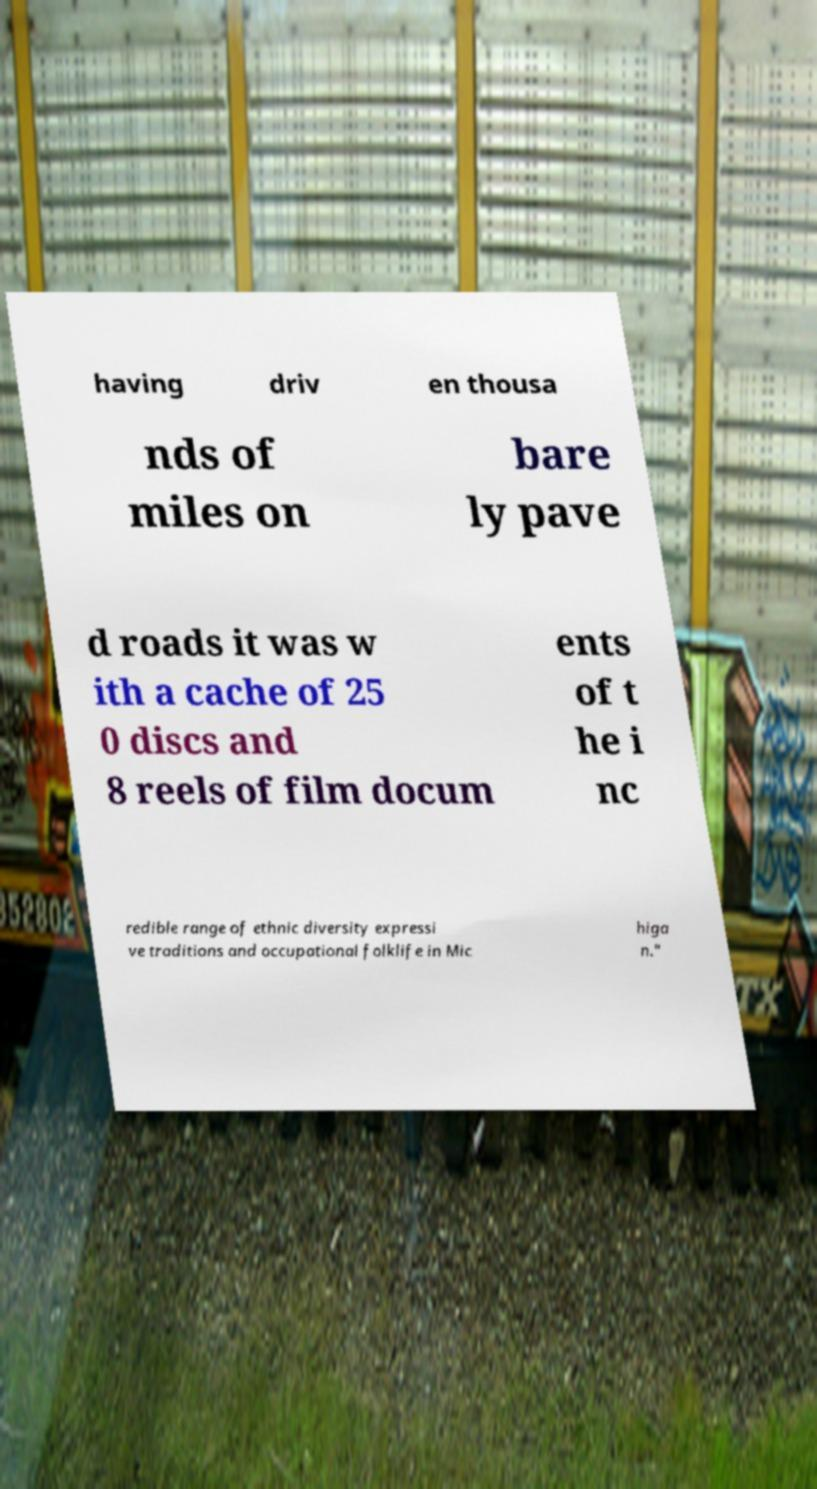There's text embedded in this image that I need extracted. Can you transcribe it verbatim? having driv en thousa nds of miles on bare ly pave d roads it was w ith a cache of 25 0 discs and 8 reels of film docum ents of t he i nc redible range of ethnic diversity expressi ve traditions and occupational folklife in Mic higa n." 